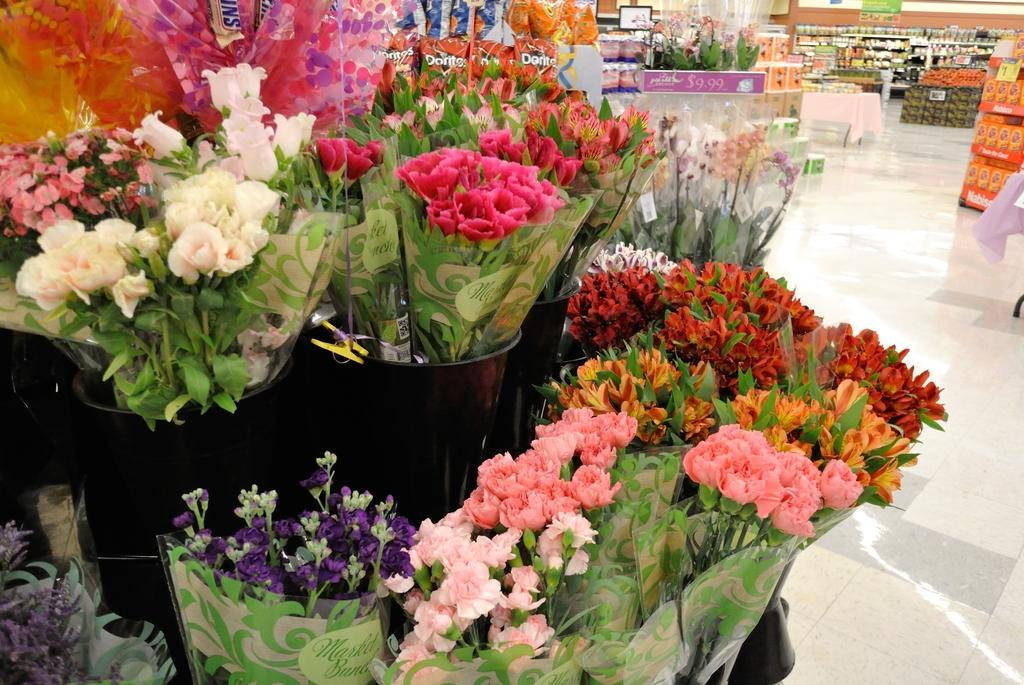What is the main subject of the image? The main subject of the image is flower bouquets. Can you describe the flowers in the bouquets? There are different types of flowers in the image. What else can be seen in the image besides the flower bouquets? There are other items visible in the backdrop of the image. What type of nut is being cracked by the person playing the guitar in the image? There is no person playing a guitar or cracking a nut present in the image; it only features flower bouquets and other unspecified items in the backdrop. 